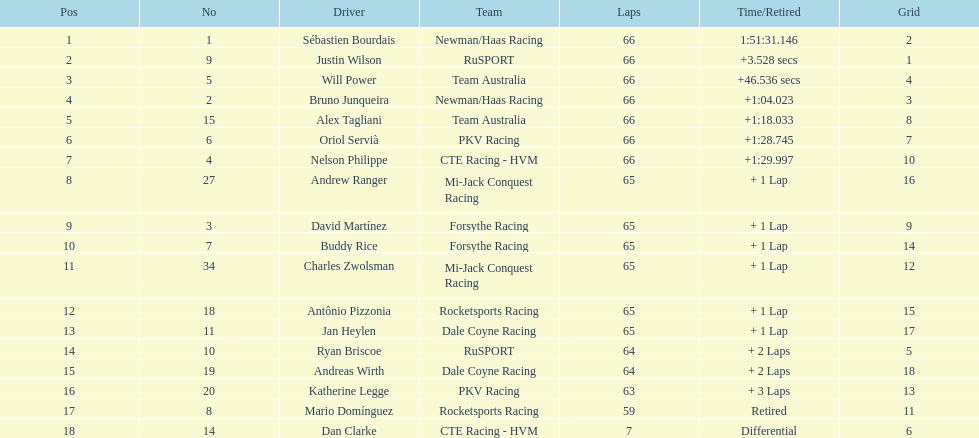Help me parse the entirety of this table. {'header': ['Pos', 'No', 'Driver', 'Team', 'Laps', 'Time/Retired', 'Grid'], 'rows': [['1', '1', 'Sébastien Bourdais', 'Newman/Haas Racing', '66', '1:51:31.146', '2'], ['2', '9', 'Justin Wilson', 'RuSPORT', '66', '+3.528 secs', '1'], ['3', '5', 'Will Power', 'Team Australia', '66', '+46.536 secs', '4'], ['4', '2', 'Bruno Junqueira', 'Newman/Haas Racing', '66', '+1:04.023', '3'], ['5', '15', 'Alex Tagliani', 'Team Australia', '66', '+1:18.033', '8'], ['6', '6', 'Oriol Servià', 'PKV Racing', '66', '+1:28.745', '7'], ['7', '4', 'Nelson Philippe', 'CTE Racing - HVM', '66', '+1:29.997', '10'], ['8', '27', 'Andrew Ranger', 'Mi-Jack Conquest Racing', '65', '+ 1 Lap', '16'], ['9', '3', 'David Martínez', 'Forsythe Racing', '65', '+ 1 Lap', '9'], ['10', '7', 'Buddy Rice', 'Forsythe Racing', '65', '+ 1 Lap', '14'], ['11', '34', 'Charles Zwolsman', 'Mi-Jack Conquest Racing', '65', '+ 1 Lap', '12'], ['12', '18', 'Antônio Pizzonia', 'Rocketsports Racing', '65', '+ 1 Lap', '15'], ['13', '11', 'Jan Heylen', 'Dale Coyne Racing', '65', '+ 1 Lap', '17'], ['14', '10', 'Ryan Briscoe', 'RuSPORT', '64', '+ 2 Laps', '5'], ['15', '19', 'Andreas Wirth', 'Dale Coyne Racing', '64', '+ 2 Laps', '18'], ['16', '20', 'Katherine Legge', 'PKV Racing', '63', '+ 3 Laps', '13'], ['17', '8', 'Mario Domínguez', 'Rocketsports Racing', '59', 'Retired', '11'], ['18', '14', 'Dan Clarke', 'CTE Racing - HVM', '7', 'Differential', '6']]} Which country is represented by the most drivers? United Kingdom. 